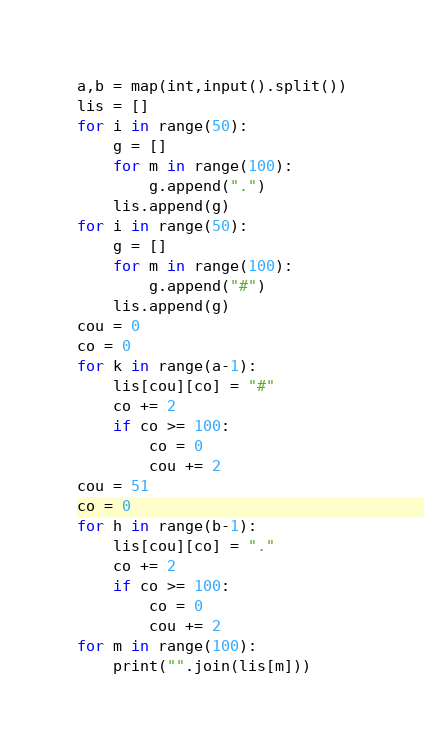<code> <loc_0><loc_0><loc_500><loc_500><_Python_>a,b = map(int,input().split())
lis = []
for i in range(50):
	g = []
	for m in range(100):
		g.append(".")
	lis.append(g)
for i in range(50):
	g = []
	for m in range(100):
		g.append("#")
	lis.append(g)
cou = 0
co = 0
for k in range(a-1):
	lis[cou][co] = "#"
	co += 2
	if co >= 100:
		co = 0
		cou += 2
cou = 51
co = 0
for h in range(b-1):
	lis[cou][co] = "."
	co += 2
	if co >= 100:
		co = 0
		cou += 2
for m in range(100):
	print("".join(lis[m]))</code> 